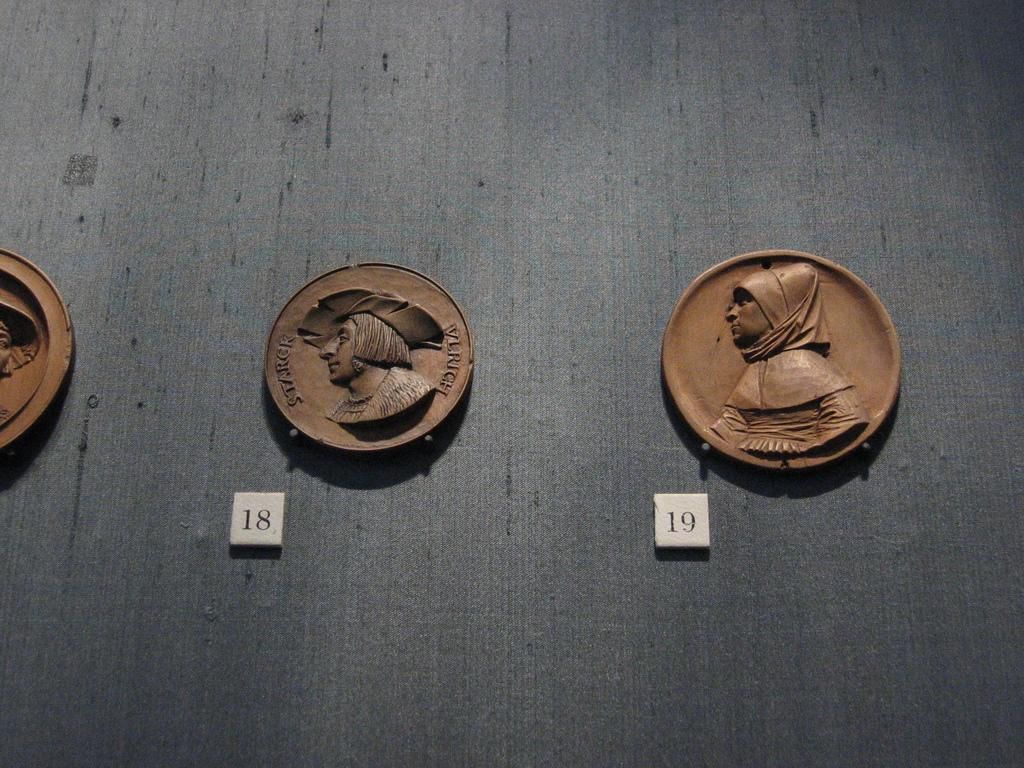<image>
Write a terse but informative summary of the picture. A line of old coins, one with the words Stark Vlrich on it 